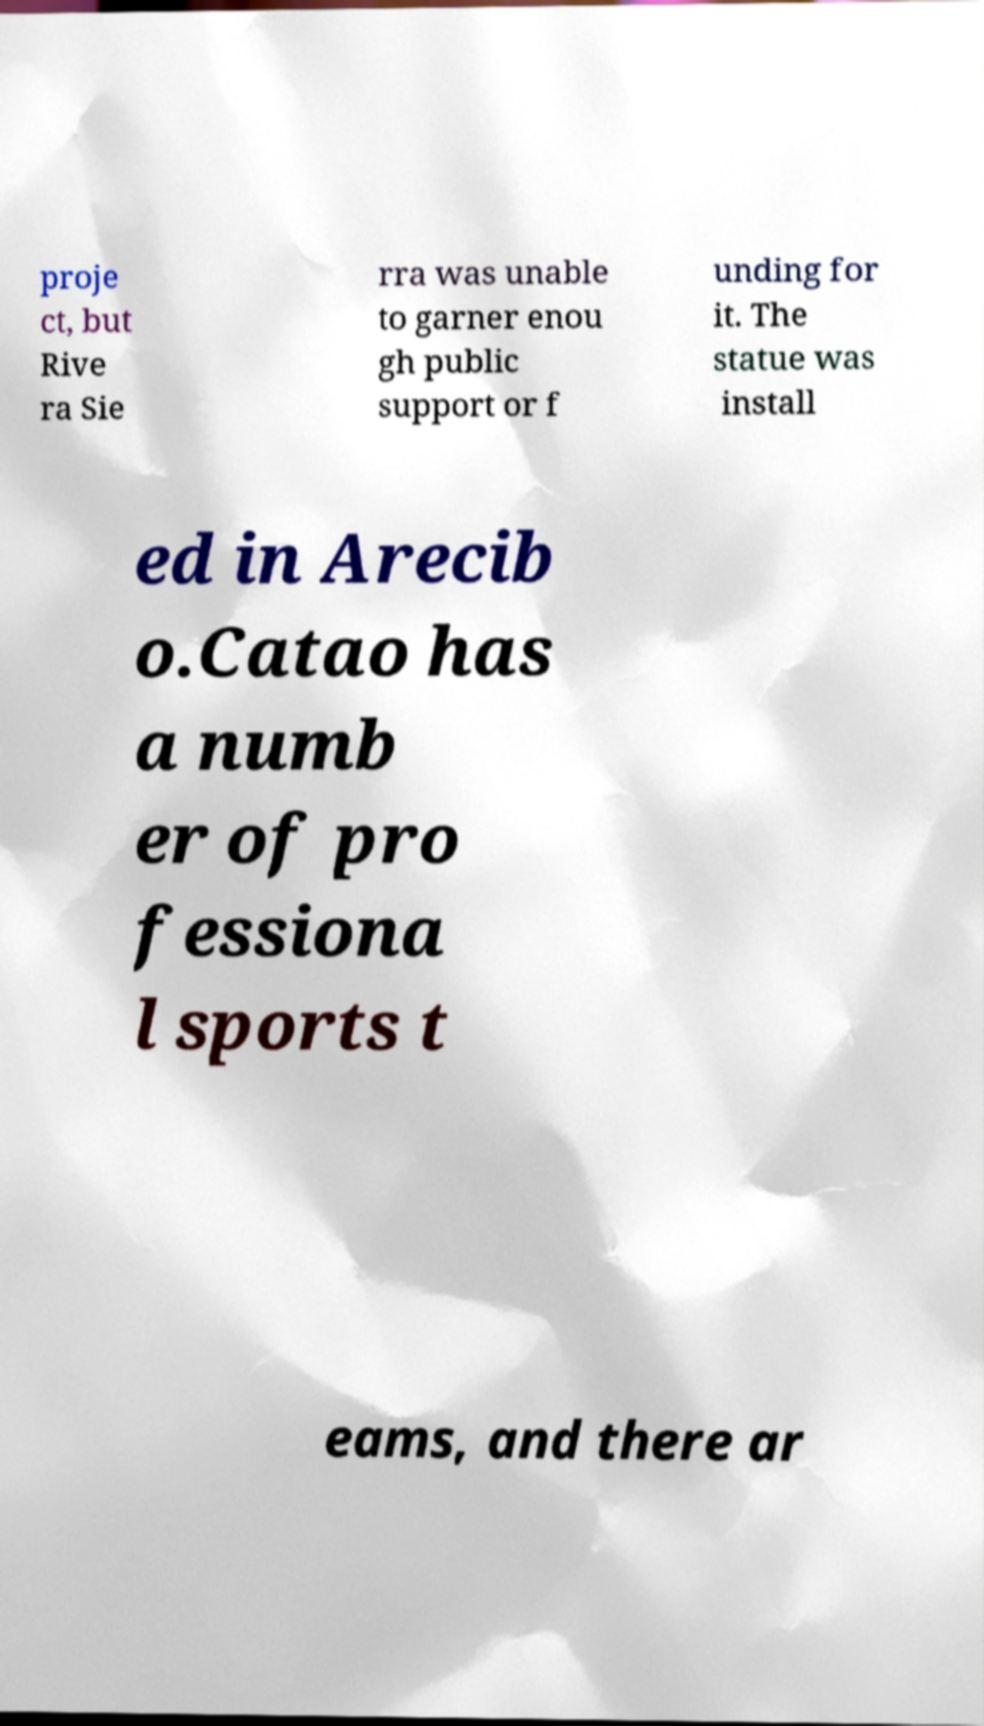Please read and relay the text visible in this image. What does it say? proje ct, but Rive ra Sie rra was unable to garner enou gh public support or f unding for it. The statue was install ed in Arecib o.Catao has a numb er of pro fessiona l sports t eams, and there ar 